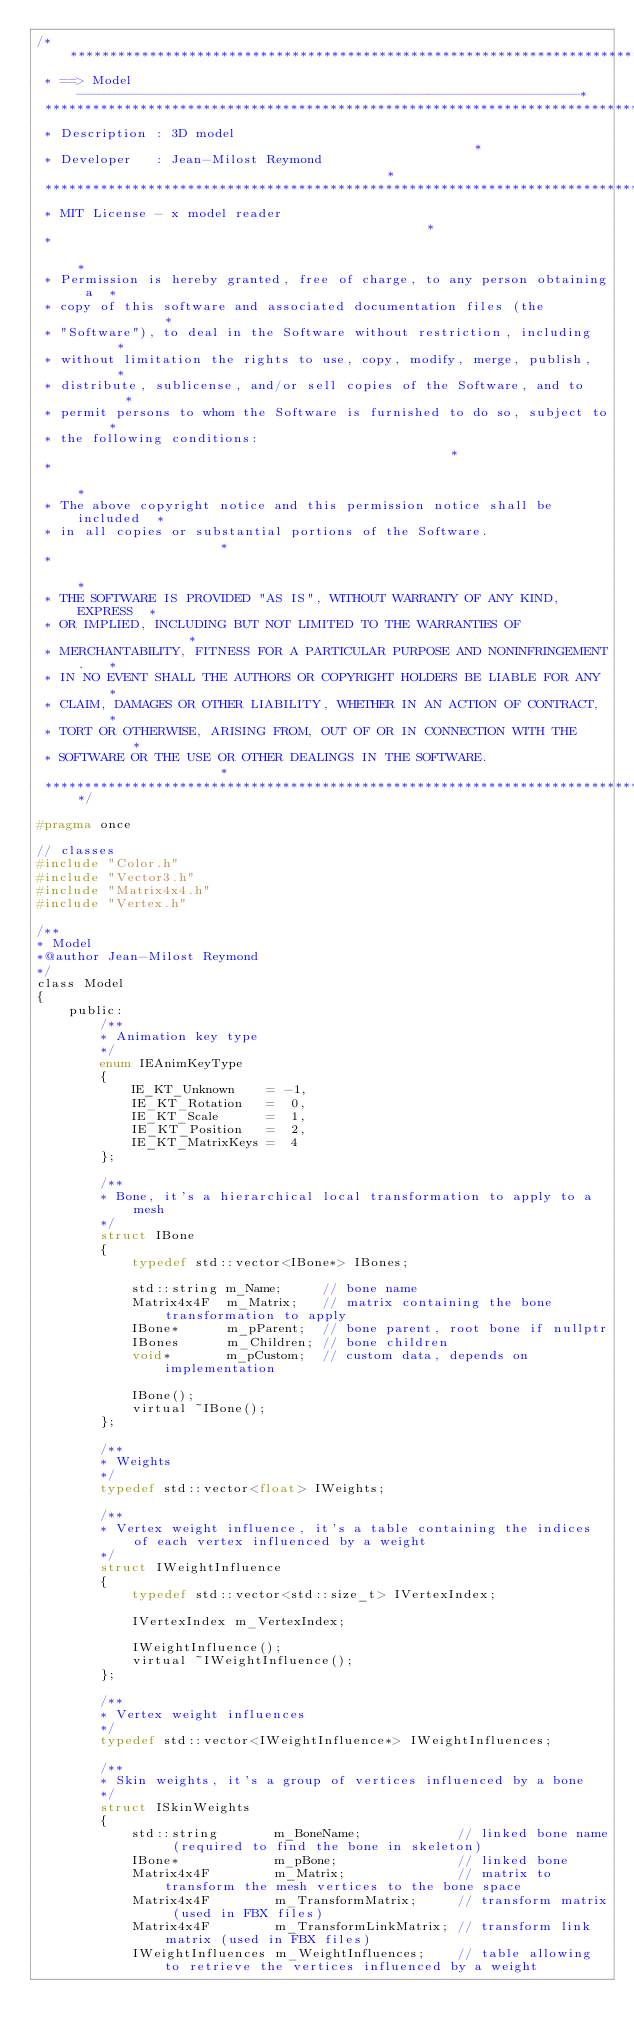Convert code to text. <code><loc_0><loc_0><loc_500><loc_500><_C_>/****************************************************************************
 * ==> Model ---------------------------------------------------------------*
 ****************************************************************************
 * Description : 3D model                                                   *
 * Developer   : Jean-Milost Reymond                                        *
 ****************************************************************************
 * MIT License - x model reader                                             *
 *                                                                          *
 * Permission is hereby granted, free of charge, to any person obtaining a  *
 * copy of this software and associated documentation files (the            *
 * "Software"), to deal in the Software without restriction, including      *
 * without limitation the rights to use, copy, modify, merge, publish,      *
 * distribute, sublicense, and/or sell copies of the Software, and to       *
 * permit persons to whom the Software is furnished to do so, subject to    *
 * the following conditions:                                                *
 *                                                                          *
 * The above copyright notice and this permission notice shall be included  *
 * in all copies or substantial portions of the Software.                   *
 *                                                                          *
 * THE SOFTWARE IS PROVIDED "AS IS", WITHOUT WARRANTY OF ANY KIND, EXPRESS  *
 * OR IMPLIED, INCLUDING BUT NOT LIMITED TO THE WARRANTIES OF               *
 * MERCHANTABILITY, FITNESS FOR A PARTICULAR PURPOSE AND NONINFRINGEMENT.   *
 * IN NO EVENT SHALL THE AUTHORS OR COPYRIGHT HOLDERS BE LIABLE FOR ANY     *
 * CLAIM, DAMAGES OR OTHER LIABILITY, WHETHER IN AN ACTION OF CONTRACT,     *
 * TORT OR OTHERWISE, ARISING FROM, OUT OF OR IN CONNECTION WITH THE        *
 * SOFTWARE OR THE USE OR OTHER DEALINGS IN THE SOFTWARE.                   *
 ****************************************************************************/

#pragma once

// classes
#include "Color.h"
#include "Vector3.h"
#include "Matrix4x4.h"
#include "Vertex.h"

/**
* Model
*@author Jean-Milost Reymond
*/
class Model
{
    public:
        /**
        * Animation key type
        */
        enum IEAnimKeyType
        {
            IE_KT_Unknown    = -1,
            IE_KT_Rotation   =  0,
            IE_KT_Scale      =  1,
            IE_KT_Position   =  2,
            IE_KT_MatrixKeys =  4
        };

        /**
        * Bone, it's a hierarchical local transformation to apply to a mesh
        */
        struct IBone
        {
            typedef std::vector<IBone*> IBones;

            std::string m_Name;     // bone name
            Matrix4x4F  m_Matrix;   // matrix containing the bone transformation to apply
            IBone*      m_pParent;  // bone parent, root bone if nullptr
            IBones      m_Children; // bone children
            void*       m_pCustom;  // custom data, depends on implementation

            IBone();
            virtual ~IBone();
        };

        /**
        * Weights
        */
        typedef std::vector<float> IWeights;

        /**
        * Vertex weight influence, it's a table containing the indices of each vertex influenced by a weight
        */
        struct IWeightInfluence
        {
            typedef std::vector<std::size_t> IVertexIndex;

            IVertexIndex m_VertexIndex;

            IWeightInfluence();
            virtual ~IWeightInfluence();
        };

        /**
        * Vertex weight influences
        */
        typedef std::vector<IWeightInfluence*> IWeightInfluences;

        /**
        * Skin weights, it's a group of vertices influenced by a bone
        */
        struct ISkinWeights
        {
            std::string       m_BoneName;            // linked bone name (required to find the bone in skeleton)
            IBone*            m_pBone;               // linked bone
            Matrix4x4F        m_Matrix;              // matrix to transform the mesh vertices to the bone space
            Matrix4x4F        m_TransformMatrix;     // transform matrix (used in FBX files)
            Matrix4x4F        m_TransformLinkMatrix; // transform link matrix (used in FBX files)
            IWeightInfluences m_WeightInfluences;    // table allowing to retrieve the vertices influenced by a weight</code> 